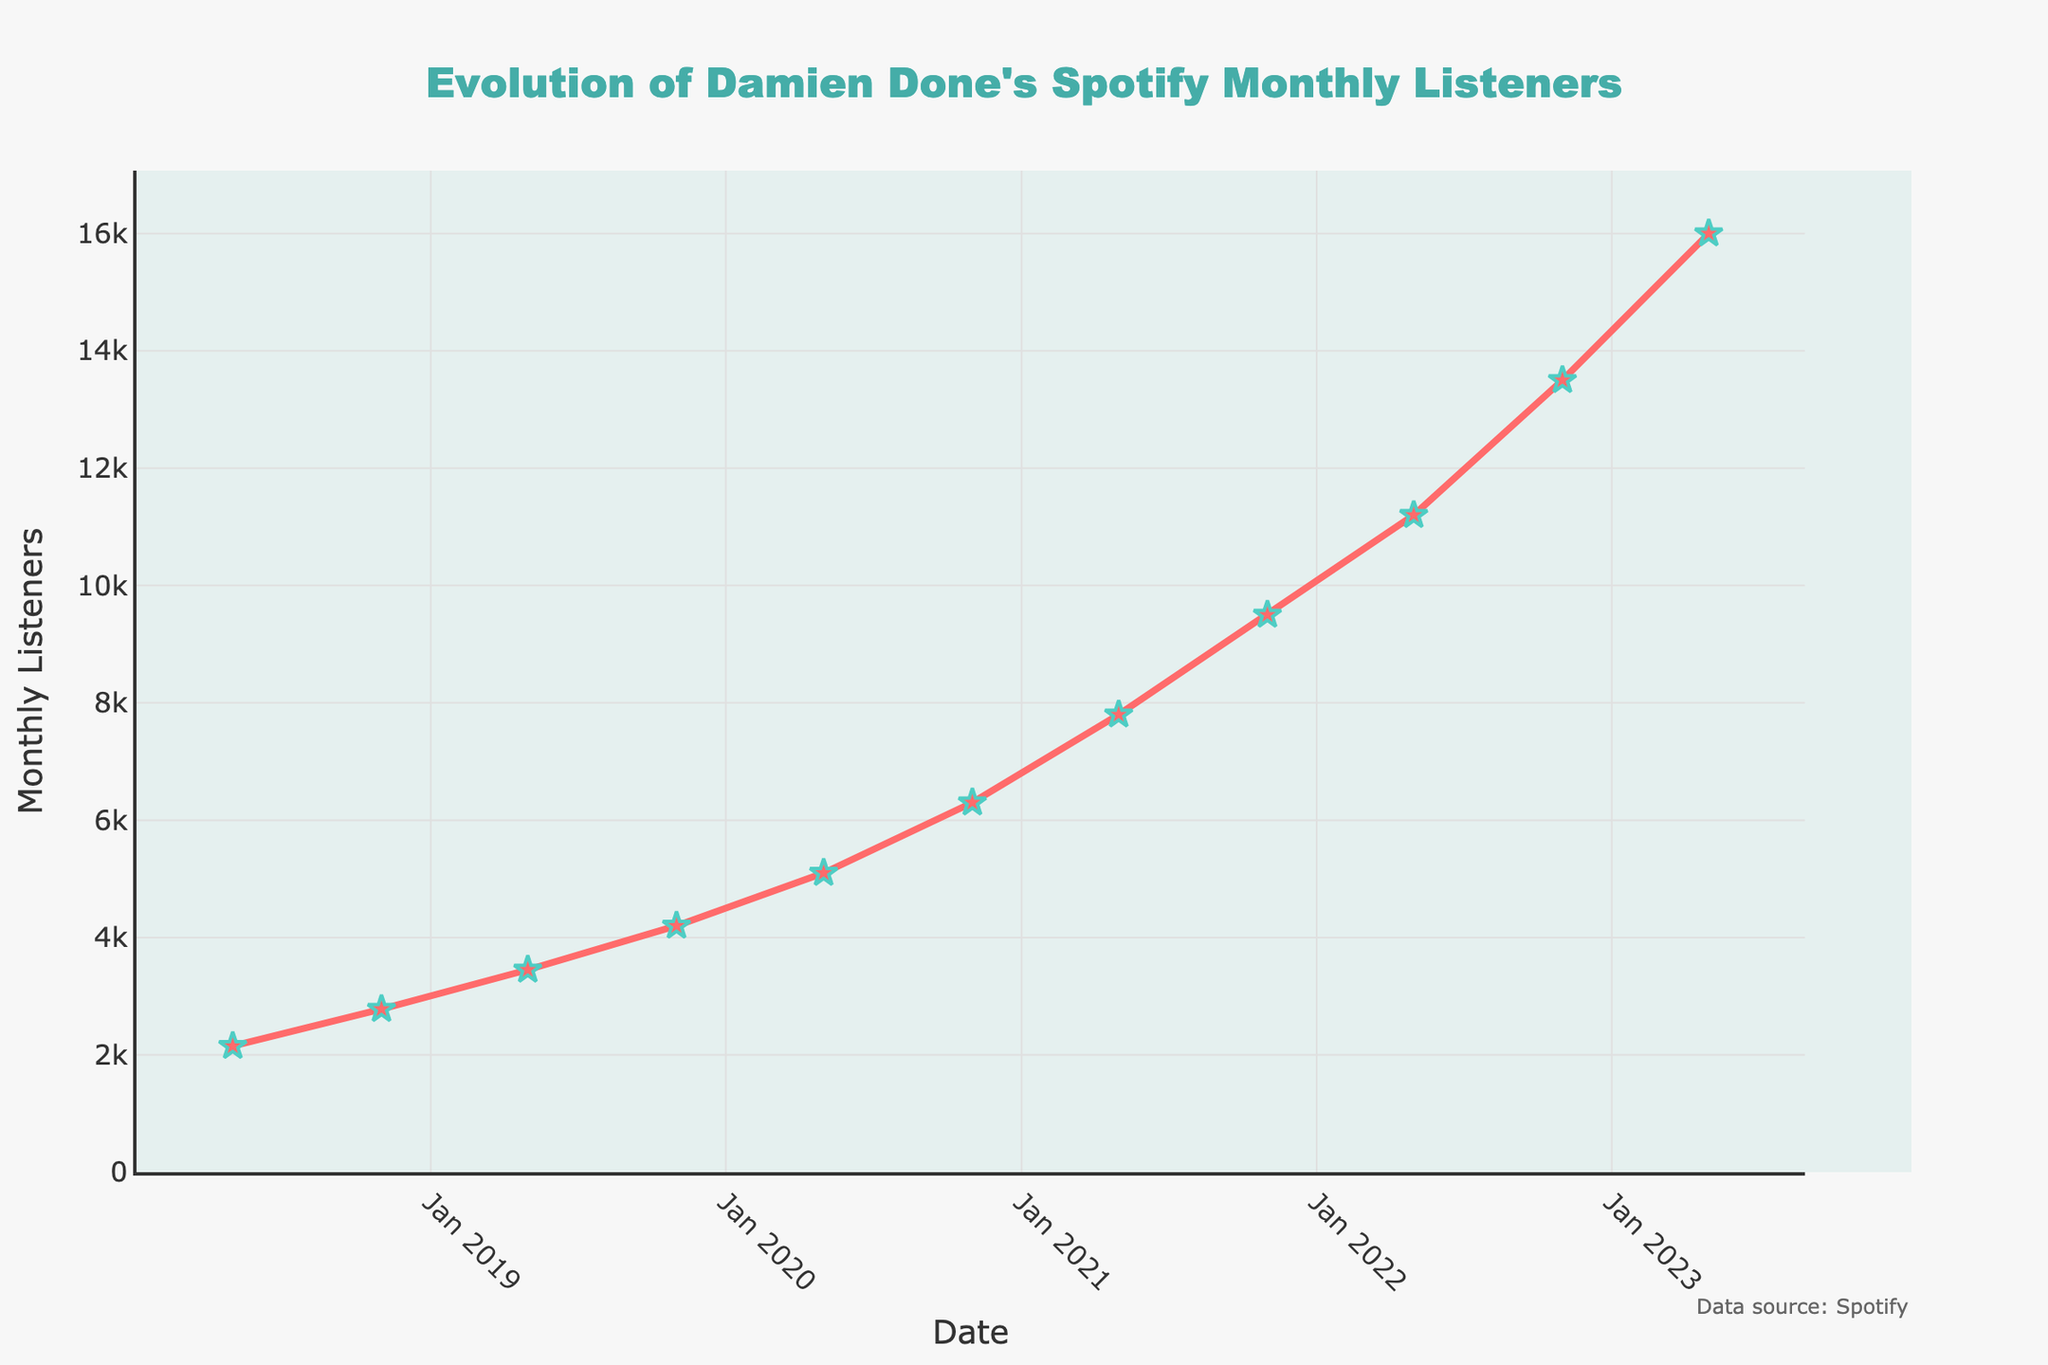What's the maximum number of monthly listeners Damien Done has had in the past 5 years? To find the maximum number of monthly listeners, identify the highest data point on the line chart. The highest point appears at the last data point (2023-05-01) with 16,000 monthly listeners.
Answer: 16,000 How many times did the number of monthly listeners increase between consecutive data points? Examine the plot to see how often the line ascends from one data point to the next. The number of monthly listeners increased at every given date, resulting in 10 continuous increases.
Answer: 10 During which period did Damien Done see the most significant increase in monthly listeners? Look for the steepest slope on the line chart, which represents the most significant increase. The steepest slope is between 2021-11-01 (9,500) and 2023-05-01 (16,000). Calculate the increase: 16,000 - 9,500 = 6,500.
Answer: Between 2021-11-01 and 2023-05-01 What was the average number of monthly listeners over the entire 5-year period? Sum all the monthly listeners data points and divide by the number of data points. Sum = 2150 + 2780 + 3450 + 4200 + 5100 + 6300 + 7800 + 9500 + 11200 + 13500 + 16000 = 79,980. There are 11 data points. So, the average is 79,980 / 11 ≈ 7,270.
Answer: 7,270 By what percentage did the monthly listeners increase from November 2020 to November 2022? Find the number of monthly listeners in November 2020 (6,300) and in November 2022 (13,500). Calculate the percentage increase: ((13,500 - 6,300) / 6,300) * 100 = 114.29%.
Answer: 114.29% What is the difference between the number of monthly listeners in May 2019 and May 2021? Identify the number of monthly listeners in May 2019 (3,450) and May 2021 (7,800). Calculate the difference: 7,800 - 3,450 = 4,350.
Answer: 4,350 What trend do you observe in the number of monthly listeners from 2018 to 2023? Observe the overall shape of the line chart. The line consistently rises from 2018 to 2023, indicating a steady increase in the number of monthly listeners over time.
Answer: Steady increase Which period had slower growth: from May 2018 to May 2020 or from May 2020 to May 2023? Calculate the increase in monthly listeners for both periods. For May 2018 (2,150) to May 2020 (5,100): 5,100 - 2,150 = 2,950. For May 2020 (5,100) to May 2023 (16,000): 16,000 - 5,100 = 10,900. Compare the two: 2,950 vs. 10,900. The growth was slower from May 2018 to May 2020.
Answer: May 2018 to May 2020 Which visual attributes indicate where the steepest increases in monthly listeners occur? Look at the steepness of the line. The steeper the line, the greater the increase in monthly listeners. The period with the steepest increase appears more vertical compared to flatter periods. The steepest increases are marked with the star-shaped markers that spread apart more vertically.
Answer: Steep line, star-shaped markers What was the increase in monthly listeners from November 2018 to November 2019? Identify the data points for November 2018 (2,780) and November 2019 (4,200). Calculate the increase: 4,200 - 2,780 = 1,420.
Answer: 1,420 